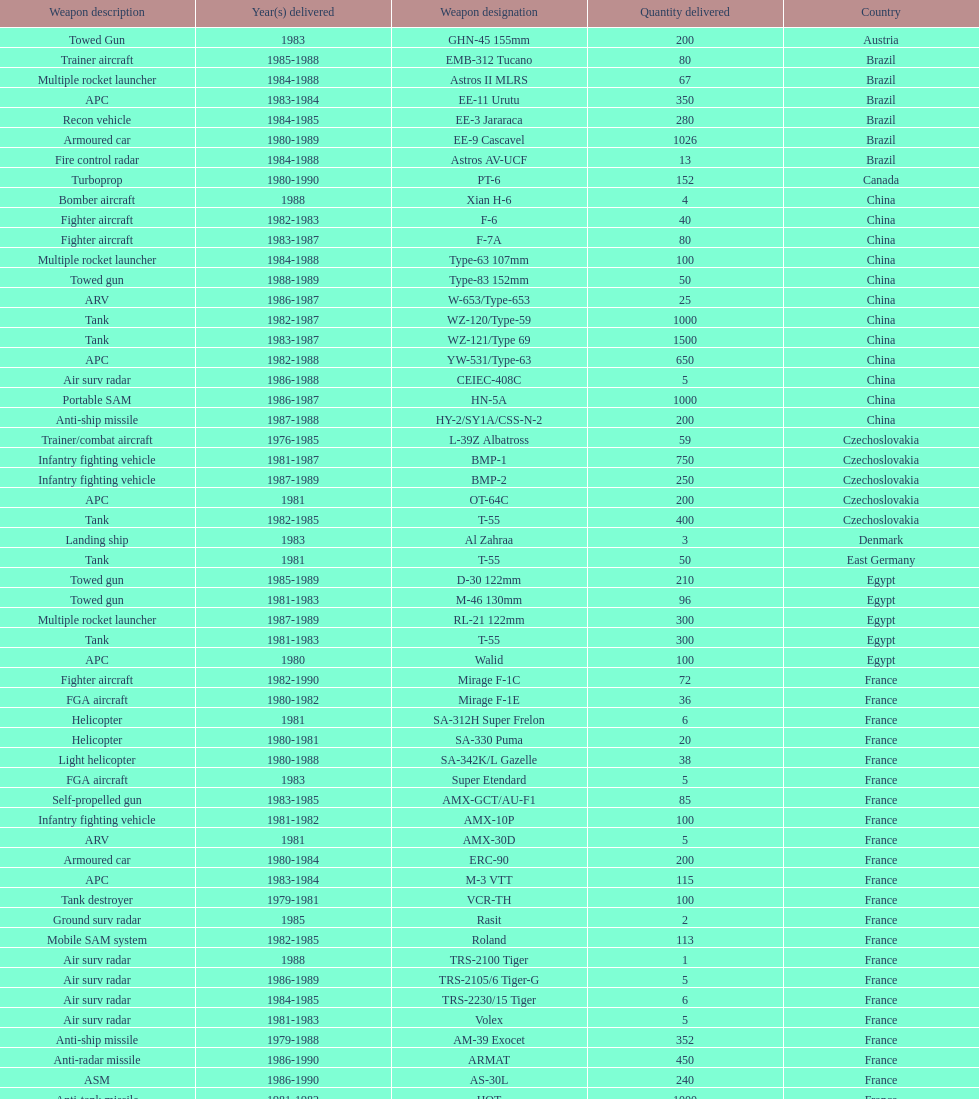Which was the first country to sell weapons to iraq? Czechoslovakia. 